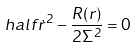<formula> <loc_0><loc_0><loc_500><loc_500>\ h a l f \dot { r } ^ { 2 } - \frac { R ( r ) } { 2 \Sigma ^ { 2 } } = 0</formula> 